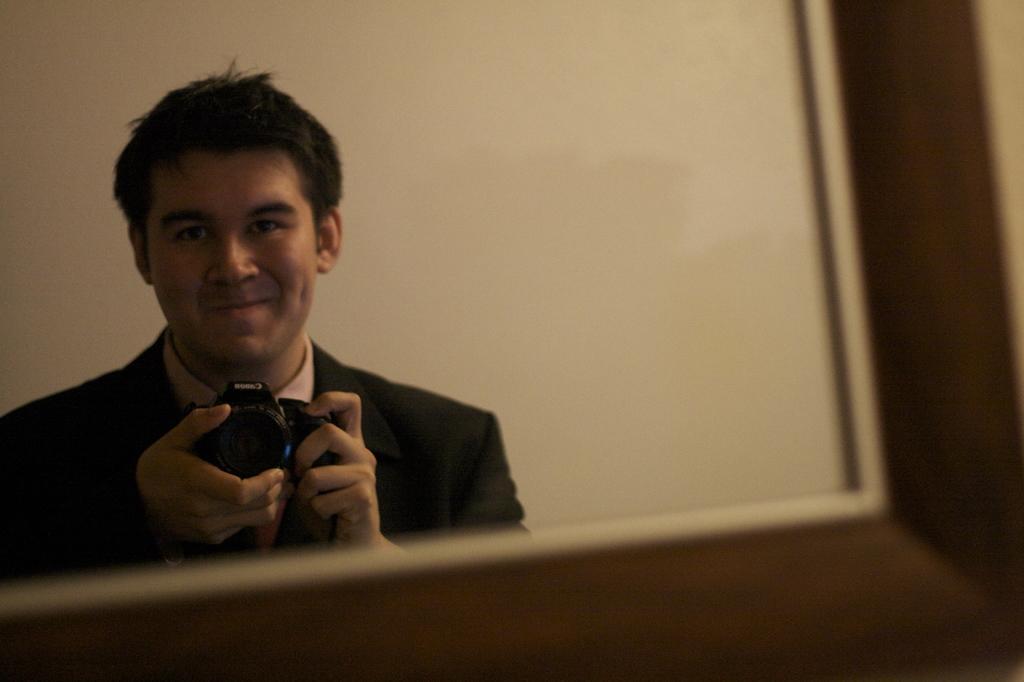In one or two sentences, can you explain what this image depicts? In this picture we can see a man holding a camera with his hands, smiling and in the background we can see the wall. 